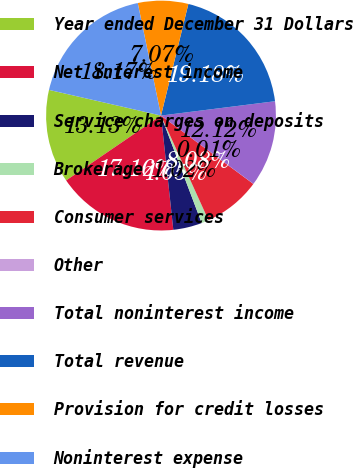<chart> <loc_0><loc_0><loc_500><loc_500><pie_chart><fcel>Year ended December 31 Dollars<fcel>Net interest income<fcel>Service charges on deposits<fcel>Brokerage<fcel>Consumer services<fcel>Other<fcel>Total noninterest income<fcel>Total revenue<fcel>Provision for credit losses<fcel>Noninterest expense<nl><fcel>13.13%<fcel>17.16%<fcel>4.05%<fcel>1.02%<fcel>8.08%<fcel>0.01%<fcel>12.12%<fcel>19.18%<fcel>7.07%<fcel>18.17%<nl></chart> 